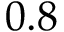Convert formula to latex. <formula><loc_0><loc_0><loc_500><loc_500>0 . 8</formula> 